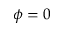<formula> <loc_0><loc_0><loc_500><loc_500>\phi = 0</formula> 